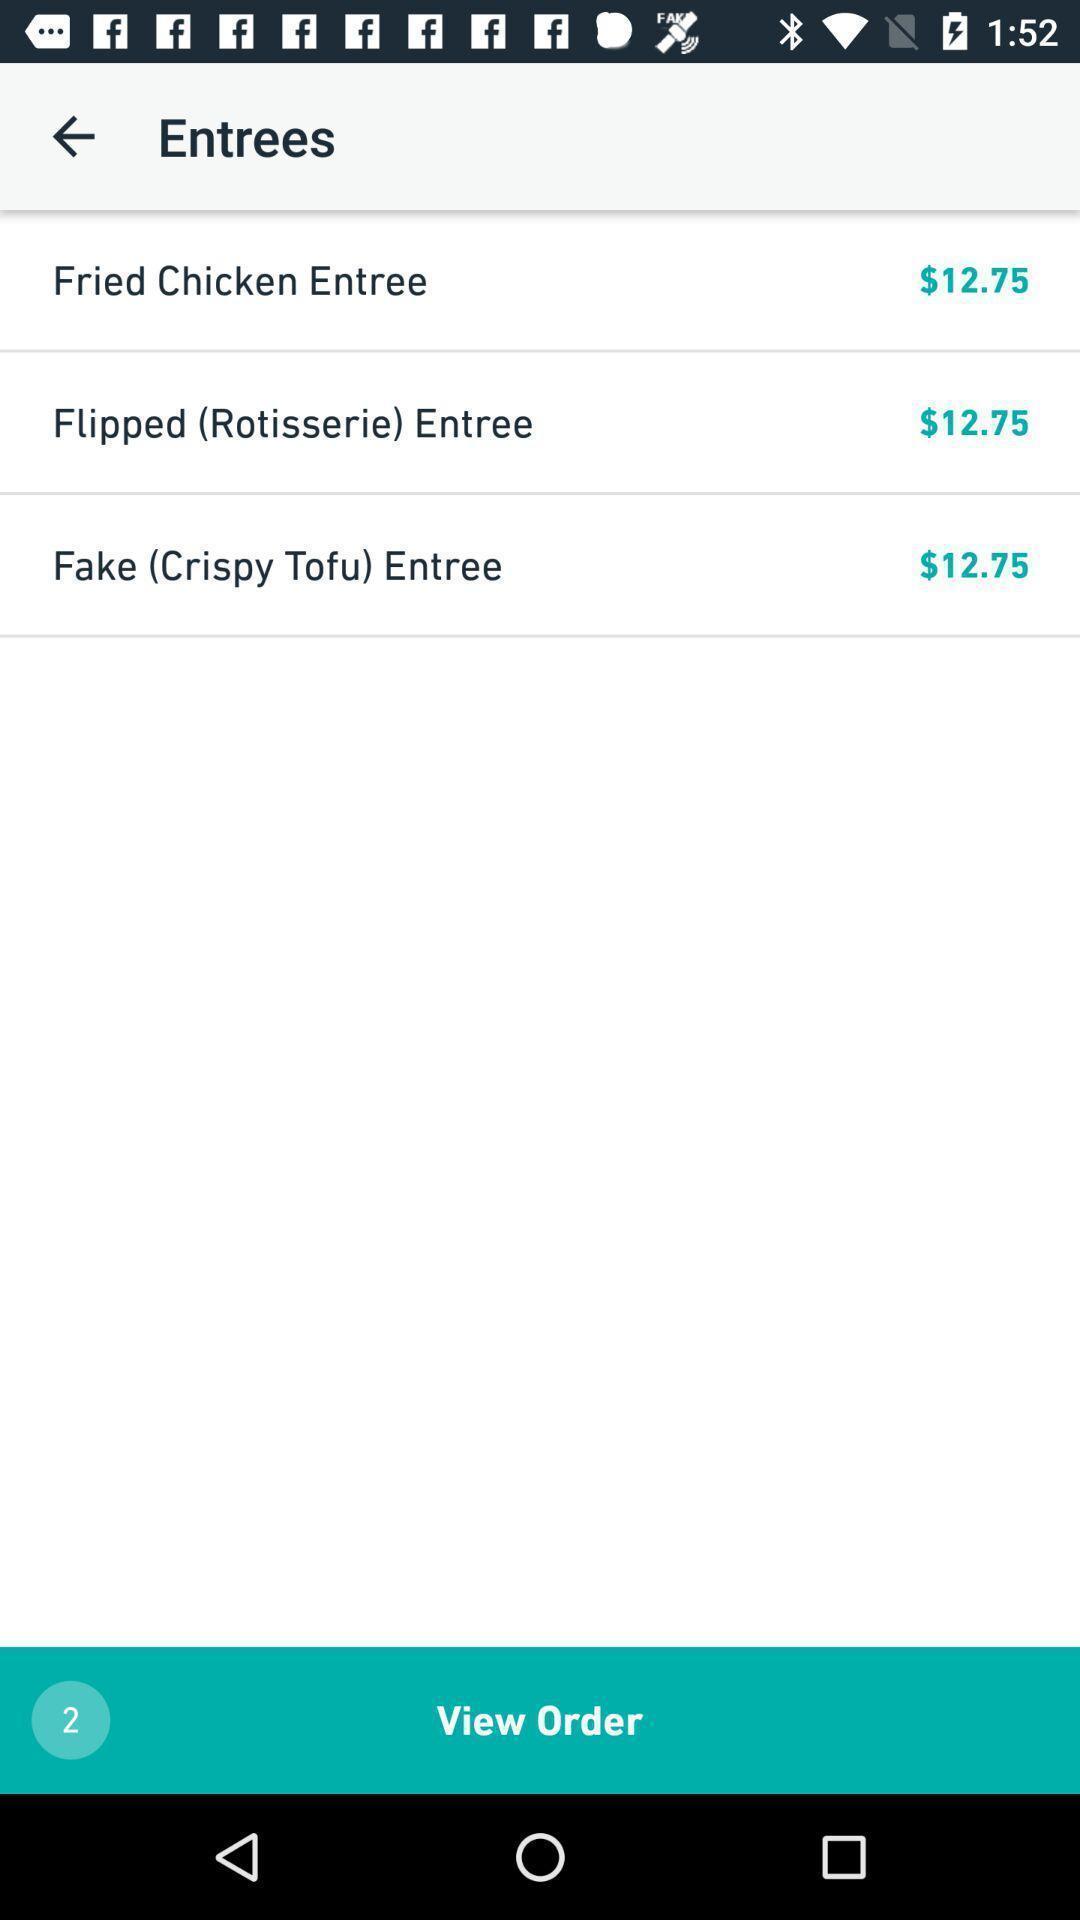Describe this image in words. Screen showing entrees. 